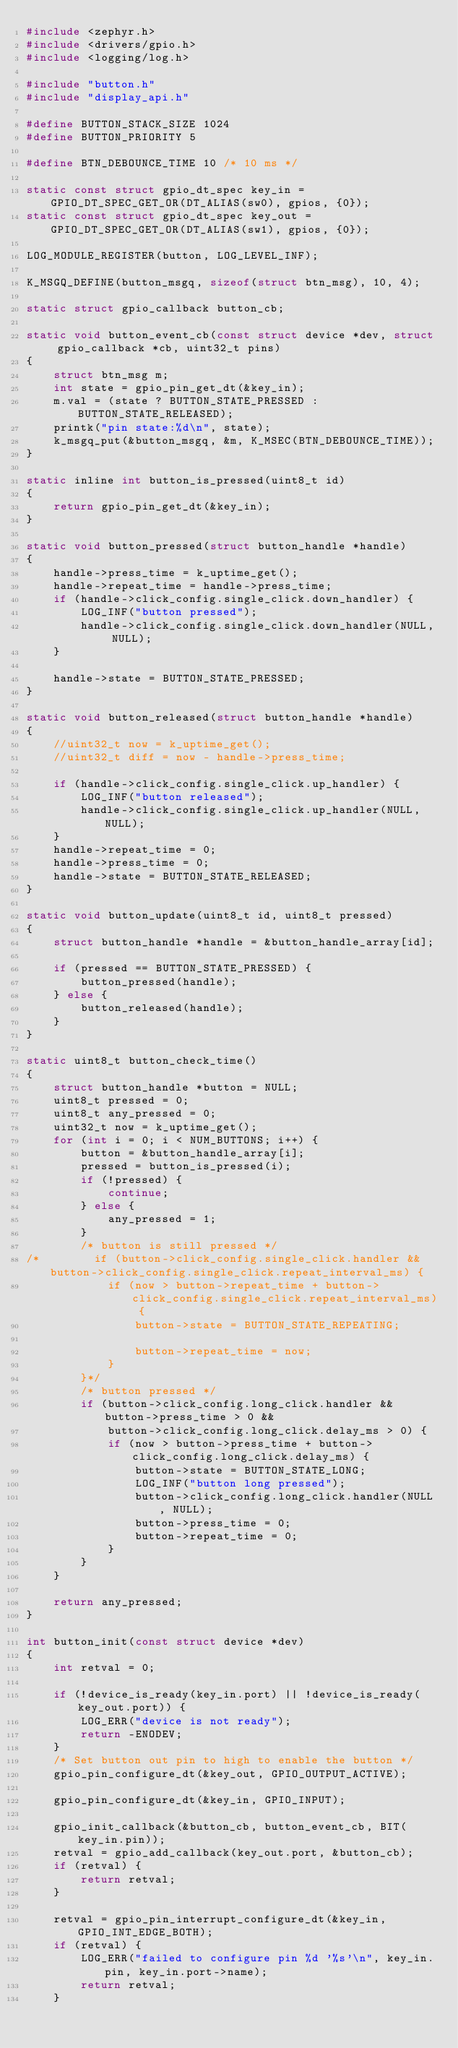<code> <loc_0><loc_0><loc_500><loc_500><_C_>#include <zephyr.h>
#include <drivers/gpio.h>
#include <logging/log.h>

#include "button.h"
#include "display_api.h"

#define BUTTON_STACK_SIZE 1024
#define BUTTON_PRIORITY 5

#define BTN_DEBOUNCE_TIME 10 /* 10 ms */

static const struct gpio_dt_spec key_in = GPIO_DT_SPEC_GET_OR(DT_ALIAS(sw0), gpios, {0});
static const struct gpio_dt_spec key_out = GPIO_DT_SPEC_GET_OR(DT_ALIAS(sw1), gpios, {0});

LOG_MODULE_REGISTER(button, LOG_LEVEL_INF);

K_MSGQ_DEFINE(button_msgq, sizeof(struct btn_msg), 10, 4);

static struct gpio_callback button_cb;

static void button_event_cb(const struct device *dev, struct gpio_callback *cb, uint32_t pins)
{
    struct btn_msg m;
    int state = gpio_pin_get_dt(&key_in);
    m.val = (state ? BUTTON_STATE_PRESSED : BUTTON_STATE_RELEASED);
    printk("pin state:%d\n", state);
    k_msgq_put(&button_msgq, &m, K_MSEC(BTN_DEBOUNCE_TIME));
}

static inline int button_is_pressed(uint8_t id)
{
    return gpio_pin_get_dt(&key_in);
}

static void button_pressed(struct button_handle *handle)
{
    handle->press_time = k_uptime_get();
    handle->repeat_time = handle->press_time;
    if (handle->click_config.single_click.down_handler) {
        LOG_INF("button pressed");
        handle->click_config.single_click.down_handler(NULL, NULL);
    }

    handle->state = BUTTON_STATE_PRESSED;
}

static void button_released(struct button_handle *handle)
{
    //uint32_t now = k_uptime_get();
    //uint32_t diff = now - handle->press_time;

    if (handle->click_config.single_click.up_handler) {
        LOG_INF("button released");
        handle->click_config.single_click.up_handler(NULL, NULL);
    }
    handle->repeat_time = 0;
    handle->press_time = 0;
    handle->state = BUTTON_STATE_RELEASED;
}

static void button_update(uint8_t id, uint8_t pressed)
{
    struct button_handle *handle = &button_handle_array[id];

    if (pressed == BUTTON_STATE_PRESSED) {
        button_pressed(handle);
    } else {
        button_released(handle);
    }
}

static uint8_t button_check_time()
{
    struct button_handle *button = NULL;
    uint8_t pressed = 0;
    uint8_t any_pressed = 0;
    uint32_t now = k_uptime_get();
    for (int i = 0; i < NUM_BUTTONS; i++) {
        button = &button_handle_array[i];
        pressed = button_is_pressed(i);
        if (!pressed) {
            continue;
        } else {
            any_pressed = 1;
        }
        /* button is still pressed */
/*        if (button->click_config.single_click.handler && button->click_config.single_click.repeat_interval_ms) {
            if (now > button->repeat_time + button->click_config.single_click.repeat_interval_ms) {
                button->state = BUTTON_STATE_REPEATING;

                button->repeat_time = now;
            }
        }*/
        /* button pressed */
        if (button->click_config.long_click.handler && button->press_time > 0 &&
            button->click_config.long_click.delay_ms > 0) {
            if (now > button->press_time + button->click_config.long_click.delay_ms) {
                button->state = BUTTON_STATE_LONG;
                LOG_INF("button long pressed");
                button->click_config.long_click.handler(NULL, NULL);
                button->press_time = 0;
                button->repeat_time = 0;
            }
        }
    }

    return any_pressed;
}

int button_init(const struct device *dev)
{
    int retval = 0;

    if (!device_is_ready(key_in.port) || !device_is_ready(key_out.port)) {
        LOG_ERR("device is not ready");
        return -ENODEV;
    }
    /* Set button out pin to high to enable the button */
    gpio_pin_configure_dt(&key_out, GPIO_OUTPUT_ACTIVE);

    gpio_pin_configure_dt(&key_in, GPIO_INPUT);

    gpio_init_callback(&button_cb, button_event_cb, BIT(key_in.pin));
    retval = gpio_add_callback(key_out.port, &button_cb);
    if (retval) {
        return retval;
    }

    retval = gpio_pin_interrupt_configure_dt(&key_in, GPIO_INT_EDGE_BOTH);
    if (retval) {
        LOG_ERR("failed to configure pin %d '%s'\n", key_in.pin, key_in.port->name);
        return retval;
    }
</code> 